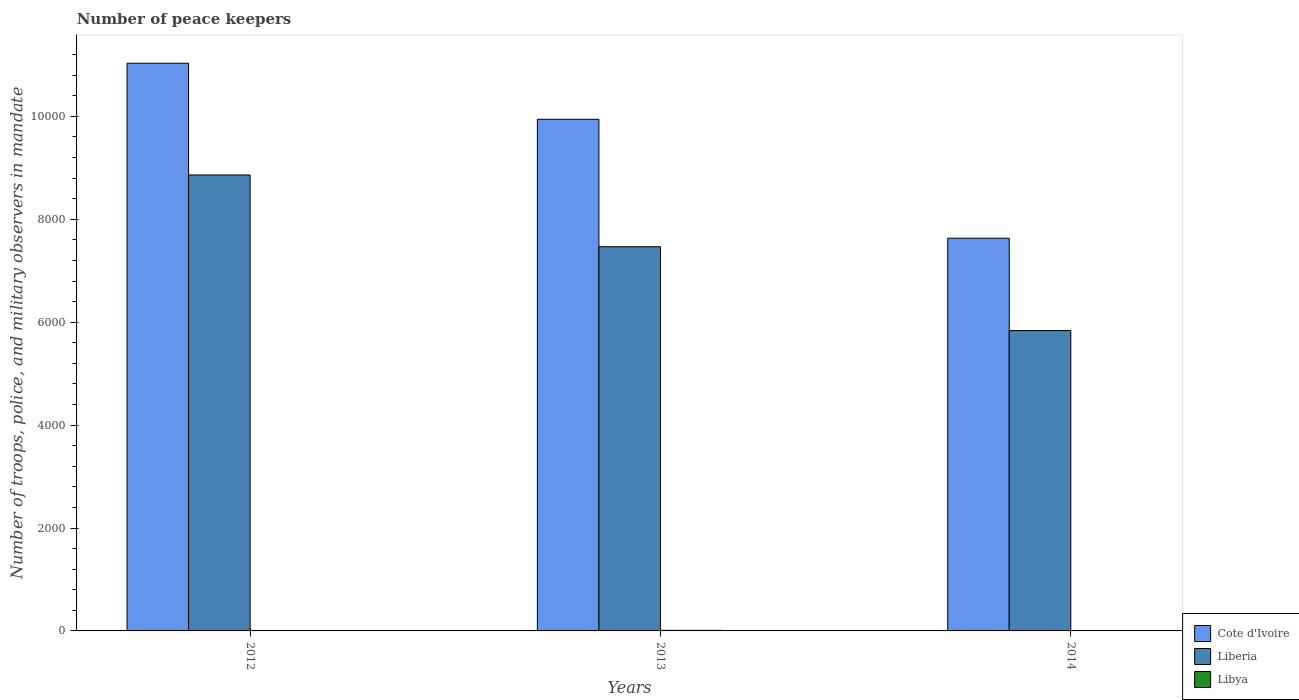In how many cases, is the number of bars for a given year not equal to the number of legend labels?
Keep it short and to the point. 0. What is the number of peace keepers in in Cote d'Ivoire in 2013?
Give a very brief answer. 9944. Across all years, what is the maximum number of peace keepers in in Cote d'Ivoire?
Offer a terse response. 1.10e+04. Across all years, what is the minimum number of peace keepers in in Libya?
Provide a succinct answer. 2. In which year was the number of peace keepers in in Liberia minimum?
Your answer should be compact. 2014. What is the total number of peace keepers in in Cote d'Ivoire in the graph?
Make the answer very short. 2.86e+04. What is the difference between the number of peace keepers in in Libya in 2013 and that in 2014?
Give a very brief answer. 9. What is the difference between the number of peace keepers in in Liberia in 2014 and the number of peace keepers in in Libya in 2013?
Provide a short and direct response. 5827. What is the average number of peace keepers in in Cote d'Ivoire per year?
Ensure brevity in your answer.  9536.67. In the year 2014, what is the difference between the number of peace keepers in in Liberia and number of peace keepers in in Libya?
Offer a terse response. 5836. In how many years, is the number of peace keepers in in Cote d'Ivoire greater than 2400?
Make the answer very short. 3. What is the ratio of the number of peace keepers in in Cote d'Ivoire in 2013 to that in 2014?
Offer a very short reply. 1.3. Is the number of peace keepers in in Cote d'Ivoire in 2013 less than that in 2014?
Provide a short and direct response. No. Is the difference between the number of peace keepers in in Liberia in 2012 and 2014 greater than the difference between the number of peace keepers in in Libya in 2012 and 2014?
Keep it short and to the point. Yes. What is the difference between the highest and the second highest number of peace keepers in in Liberia?
Offer a terse response. 1395. What is the difference between the highest and the lowest number of peace keepers in in Libya?
Offer a terse response. 9. What does the 3rd bar from the left in 2013 represents?
Make the answer very short. Libya. What does the 2nd bar from the right in 2013 represents?
Keep it short and to the point. Liberia. Is it the case that in every year, the sum of the number of peace keepers in in Cote d'Ivoire and number of peace keepers in in Libya is greater than the number of peace keepers in in Liberia?
Provide a succinct answer. Yes. How many bars are there?
Make the answer very short. 9. How many years are there in the graph?
Provide a short and direct response. 3. What is the difference between two consecutive major ticks on the Y-axis?
Offer a very short reply. 2000. Are the values on the major ticks of Y-axis written in scientific E-notation?
Offer a terse response. No. What is the title of the graph?
Your response must be concise. Number of peace keepers. Does "Virgin Islands" appear as one of the legend labels in the graph?
Offer a very short reply. No. What is the label or title of the Y-axis?
Give a very brief answer. Number of troops, police, and military observers in mandate. What is the Number of troops, police, and military observers in mandate in Cote d'Ivoire in 2012?
Give a very brief answer. 1.10e+04. What is the Number of troops, police, and military observers in mandate of Liberia in 2012?
Keep it short and to the point. 8862. What is the Number of troops, police, and military observers in mandate of Cote d'Ivoire in 2013?
Keep it short and to the point. 9944. What is the Number of troops, police, and military observers in mandate of Liberia in 2013?
Offer a terse response. 7467. What is the Number of troops, police, and military observers in mandate of Cote d'Ivoire in 2014?
Offer a terse response. 7633. What is the Number of troops, police, and military observers in mandate in Liberia in 2014?
Your answer should be very brief. 5838. What is the Number of troops, police, and military observers in mandate in Libya in 2014?
Your answer should be compact. 2. Across all years, what is the maximum Number of troops, police, and military observers in mandate in Cote d'Ivoire?
Offer a very short reply. 1.10e+04. Across all years, what is the maximum Number of troops, police, and military observers in mandate in Liberia?
Offer a very short reply. 8862. Across all years, what is the maximum Number of troops, police, and military observers in mandate in Libya?
Keep it short and to the point. 11. Across all years, what is the minimum Number of troops, police, and military observers in mandate of Cote d'Ivoire?
Your response must be concise. 7633. Across all years, what is the minimum Number of troops, police, and military observers in mandate of Liberia?
Ensure brevity in your answer.  5838. Across all years, what is the minimum Number of troops, police, and military observers in mandate in Libya?
Your answer should be very brief. 2. What is the total Number of troops, police, and military observers in mandate in Cote d'Ivoire in the graph?
Your answer should be very brief. 2.86e+04. What is the total Number of troops, police, and military observers in mandate of Liberia in the graph?
Offer a terse response. 2.22e+04. What is the total Number of troops, police, and military observers in mandate of Libya in the graph?
Provide a succinct answer. 15. What is the difference between the Number of troops, police, and military observers in mandate of Cote d'Ivoire in 2012 and that in 2013?
Make the answer very short. 1089. What is the difference between the Number of troops, police, and military observers in mandate in Liberia in 2012 and that in 2013?
Give a very brief answer. 1395. What is the difference between the Number of troops, police, and military observers in mandate in Cote d'Ivoire in 2012 and that in 2014?
Offer a very short reply. 3400. What is the difference between the Number of troops, police, and military observers in mandate of Liberia in 2012 and that in 2014?
Offer a terse response. 3024. What is the difference between the Number of troops, police, and military observers in mandate in Libya in 2012 and that in 2014?
Keep it short and to the point. 0. What is the difference between the Number of troops, police, and military observers in mandate in Cote d'Ivoire in 2013 and that in 2014?
Provide a succinct answer. 2311. What is the difference between the Number of troops, police, and military observers in mandate in Liberia in 2013 and that in 2014?
Provide a succinct answer. 1629. What is the difference between the Number of troops, police, and military observers in mandate in Cote d'Ivoire in 2012 and the Number of troops, police, and military observers in mandate in Liberia in 2013?
Make the answer very short. 3566. What is the difference between the Number of troops, police, and military observers in mandate in Cote d'Ivoire in 2012 and the Number of troops, police, and military observers in mandate in Libya in 2013?
Provide a succinct answer. 1.10e+04. What is the difference between the Number of troops, police, and military observers in mandate in Liberia in 2012 and the Number of troops, police, and military observers in mandate in Libya in 2013?
Give a very brief answer. 8851. What is the difference between the Number of troops, police, and military observers in mandate of Cote d'Ivoire in 2012 and the Number of troops, police, and military observers in mandate of Liberia in 2014?
Give a very brief answer. 5195. What is the difference between the Number of troops, police, and military observers in mandate of Cote d'Ivoire in 2012 and the Number of troops, police, and military observers in mandate of Libya in 2014?
Provide a succinct answer. 1.10e+04. What is the difference between the Number of troops, police, and military observers in mandate of Liberia in 2012 and the Number of troops, police, and military observers in mandate of Libya in 2014?
Offer a terse response. 8860. What is the difference between the Number of troops, police, and military observers in mandate of Cote d'Ivoire in 2013 and the Number of troops, police, and military observers in mandate of Liberia in 2014?
Make the answer very short. 4106. What is the difference between the Number of troops, police, and military observers in mandate of Cote d'Ivoire in 2013 and the Number of troops, police, and military observers in mandate of Libya in 2014?
Provide a succinct answer. 9942. What is the difference between the Number of troops, police, and military observers in mandate of Liberia in 2013 and the Number of troops, police, and military observers in mandate of Libya in 2014?
Provide a short and direct response. 7465. What is the average Number of troops, police, and military observers in mandate of Cote d'Ivoire per year?
Make the answer very short. 9536.67. What is the average Number of troops, police, and military observers in mandate in Liberia per year?
Keep it short and to the point. 7389. What is the average Number of troops, police, and military observers in mandate in Libya per year?
Your answer should be very brief. 5. In the year 2012, what is the difference between the Number of troops, police, and military observers in mandate of Cote d'Ivoire and Number of troops, police, and military observers in mandate of Liberia?
Provide a short and direct response. 2171. In the year 2012, what is the difference between the Number of troops, police, and military observers in mandate of Cote d'Ivoire and Number of troops, police, and military observers in mandate of Libya?
Offer a very short reply. 1.10e+04. In the year 2012, what is the difference between the Number of troops, police, and military observers in mandate of Liberia and Number of troops, police, and military observers in mandate of Libya?
Provide a short and direct response. 8860. In the year 2013, what is the difference between the Number of troops, police, and military observers in mandate of Cote d'Ivoire and Number of troops, police, and military observers in mandate of Liberia?
Ensure brevity in your answer.  2477. In the year 2013, what is the difference between the Number of troops, police, and military observers in mandate in Cote d'Ivoire and Number of troops, police, and military observers in mandate in Libya?
Offer a very short reply. 9933. In the year 2013, what is the difference between the Number of troops, police, and military observers in mandate of Liberia and Number of troops, police, and military observers in mandate of Libya?
Ensure brevity in your answer.  7456. In the year 2014, what is the difference between the Number of troops, police, and military observers in mandate of Cote d'Ivoire and Number of troops, police, and military observers in mandate of Liberia?
Offer a very short reply. 1795. In the year 2014, what is the difference between the Number of troops, police, and military observers in mandate of Cote d'Ivoire and Number of troops, police, and military observers in mandate of Libya?
Keep it short and to the point. 7631. In the year 2014, what is the difference between the Number of troops, police, and military observers in mandate in Liberia and Number of troops, police, and military observers in mandate in Libya?
Make the answer very short. 5836. What is the ratio of the Number of troops, police, and military observers in mandate of Cote d'Ivoire in 2012 to that in 2013?
Your answer should be very brief. 1.11. What is the ratio of the Number of troops, police, and military observers in mandate of Liberia in 2012 to that in 2013?
Provide a succinct answer. 1.19. What is the ratio of the Number of troops, police, and military observers in mandate in Libya in 2012 to that in 2013?
Keep it short and to the point. 0.18. What is the ratio of the Number of troops, police, and military observers in mandate of Cote d'Ivoire in 2012 to that in 2014?
Ensure brevity in your answer.  1.45. What is the ratio of the Number of troops, police, and military observers in mandate in Liberia in 2012 to that in 2014?
Offer a terse response. 1.52. What is the ratio of the Number of troops, police, and military observers in mandate in Cote d'Ivoire in 2013 to that in 2014?
Offer a terse response. 1.3. What is the ratio of the Number of troops, police, and military observers in mandate in Liberia in 2013 to that in 2014?
Provide a short and direct response. 1.28. What is the difference between the highest and the second highest Number of troops, police, and military observers in mandate in Cote d'Ivoire?
Give a very brief answer. 1089. What is the difference between the highest and the second highest Number of troops, police, and military observers in mandate of Liberia?
Your answer should be compact. 1395. What is the difference between the highest and the lowest Number of troops, police, and military observers in mandate in Cote d'Ivoire?
Your answer should be compact. 3400. What is the difference between the highest and the lowest Number of troops, police, and military observers in mandate of Liberia?
Your response must be concise. 3024. 